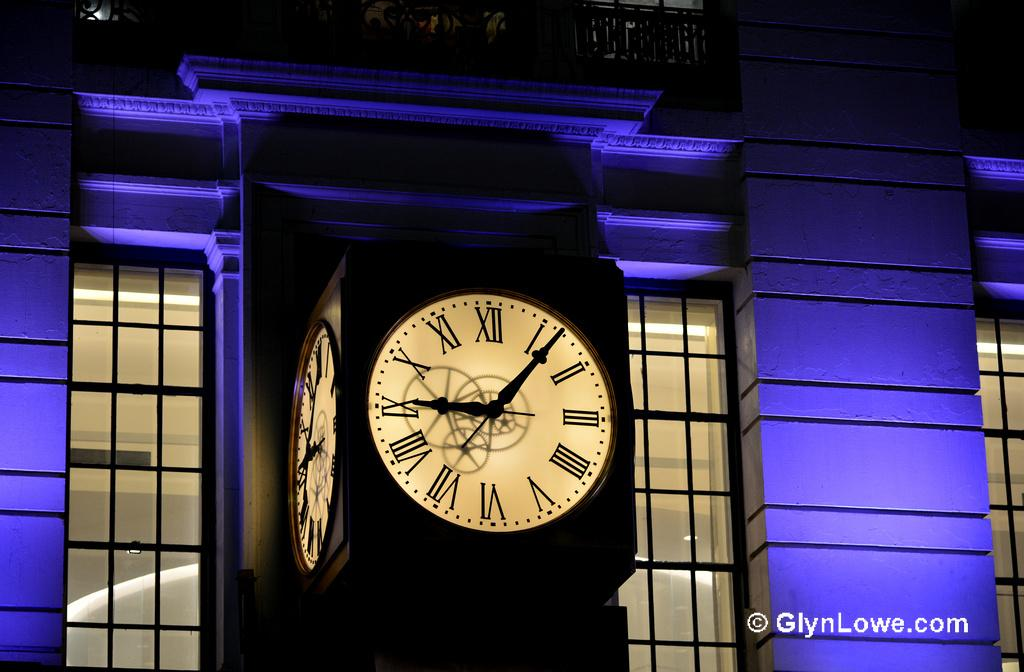Provide a one-sentence caption for the provided image. A photo from GlynLowe.com shows a clocktower at night. 